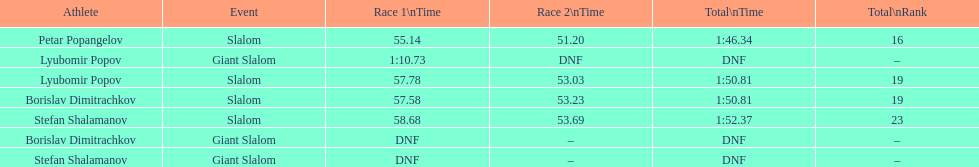Who came after borislav dimitrachkov and it's time for slalom Petar Popangelov. 